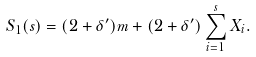Convert formula to latex. <formula><loc_0><loc_0><loc_500><loc_500>S _ { 1 } ( s ) = ( 2 + \delta ^ { \prime } ) m + ( 2 + \delta ^ { \prime } ) \sum _ { i = 1 } ^ { s } X _ { i } .</formula> 